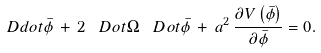Convert formula to latex. <formula><loc_0><loc_0><loc_500><loc_500>\ D d o t { \bar { \phi } } \, + \, 2 \, \ D o t { \Omega } \, \ D o t { \bar { \phi } } \, + \, a ^ { 2 } \, \frac { \partial V \left ( \bar { \phi } \right ) } { \partial \bar { \phi } } = 0 .</formula> 